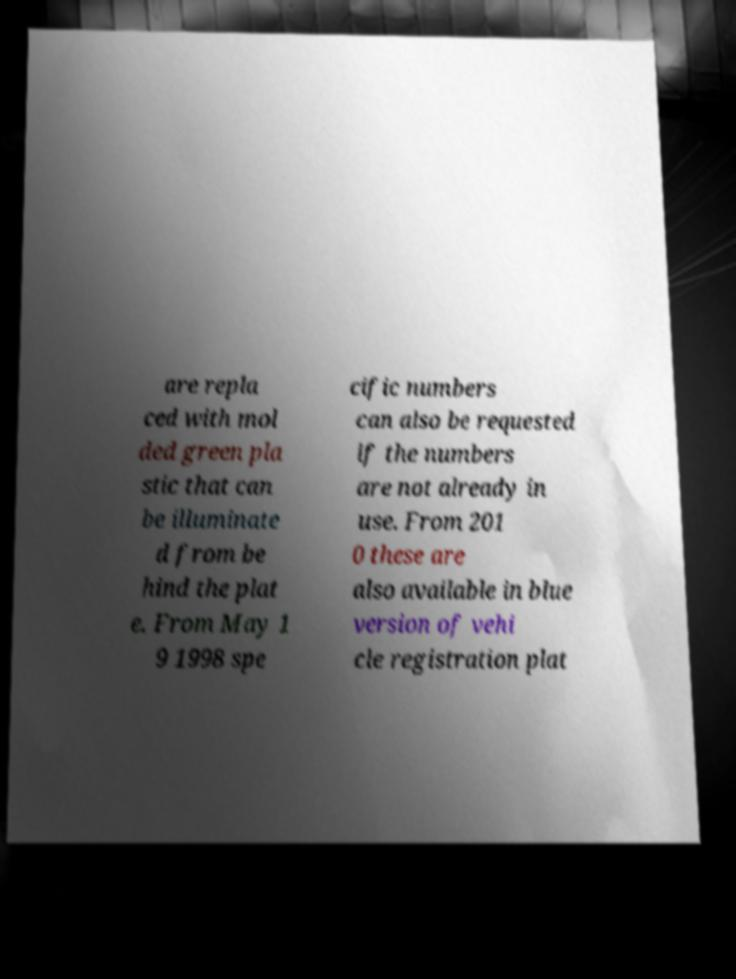Can you read and provide the text displayed in the image?This photo seems to have some interesting text. Can you extract and type it out for me? are repla ced with mol ded green pla stic that can be illuminate d from be hind the plat e. From May 1 9 1998 spe cific numbers can also be requested if the numbers are not already in use. From 201 0 these are also available in blue version of vehi cle registration plat 